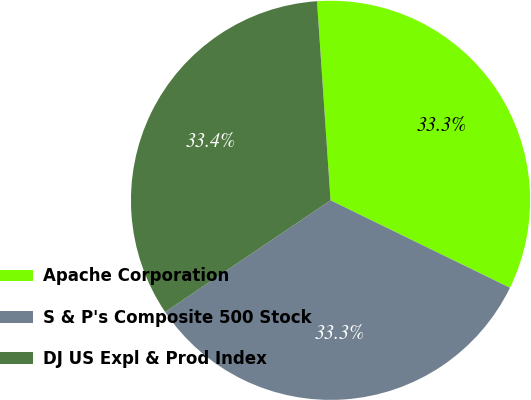<chart> <loc_0><loc_0><loc_500><loc_500><pie_chart><fcel>Apache Corporation<fcel>S & P's Composite 500 Stock<fcel>DJ US Expl & Prod Index<nl><fcel>33.3%<fcel>33.33%<fcel>33.37%<nl></chart> 